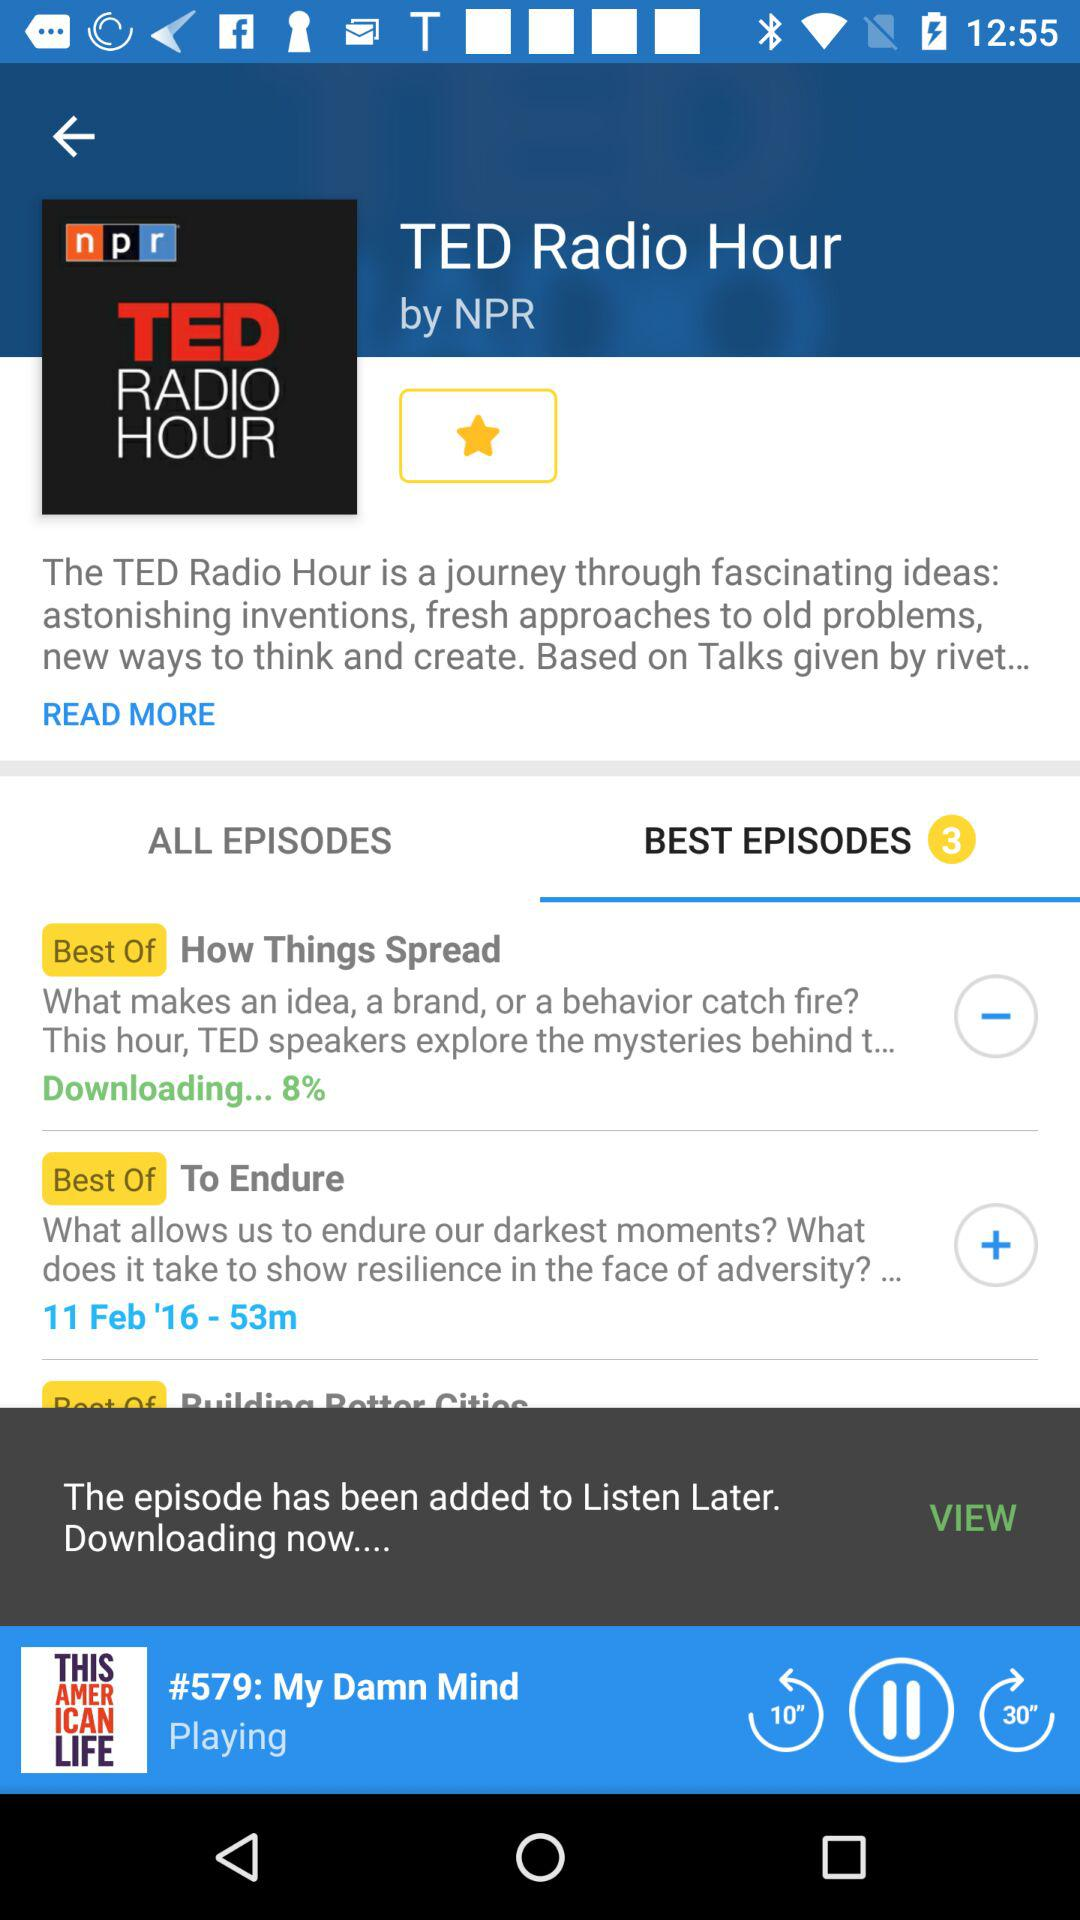How many best episodes are there? There are 3 best episodes. 